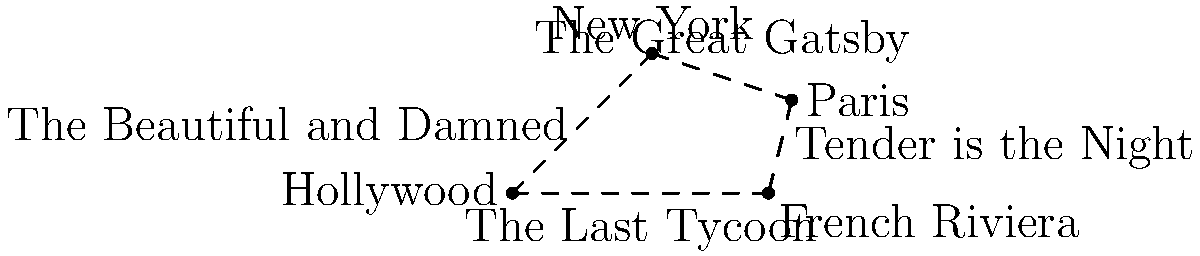Based on the stylized map of geographical settings in F. Scott Fitzgerald's works, which novel is correctly paired with its primary setting? To answer this question, we need to analyze the map and connect each novel with its primary setting:

1. "The Great Gatsby" is positioned between New York and Paris. However, the novel is primarily set in New York, specifically Long Island.

2. "Tender is the Night" is placed between Paris and the French Riviera. This novel is indeed set primarily on the French Riviera, with some scenes in Paris.

3. "The Last Tycoon" (also known as "The Love of the Last Tycoon") is shown between the French Riviera and Hollywood. This unfinished novel is actually set in Hollywood.

4. "The Beautiful and Damned" is depicted between Hollywood and New York. This novel is primarily set in New York City.

Given these associations, the novel that is correctly paired with its primary setting is "Tender is the Night" with the French Riviera.
Answer: Tender is the Night 